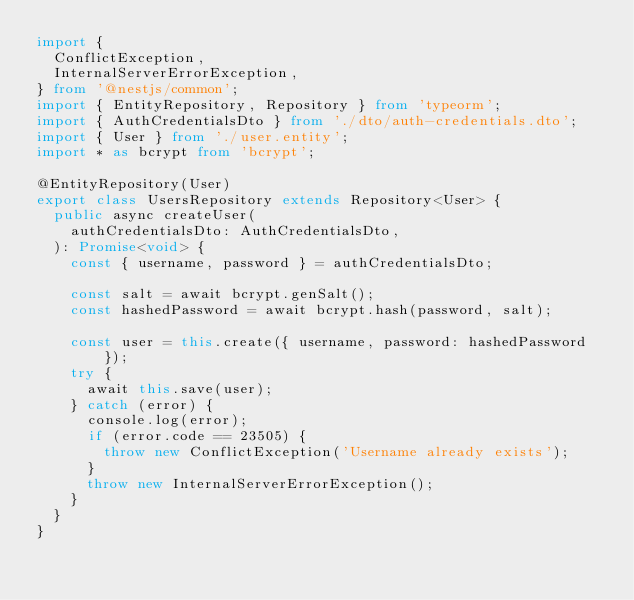Convert code to text. <code><loc_0><loc_0><loc_500><loc_500><_TypeScript_>import {
  ConflictException,
  InternalServerErrorException,
} from '@nestjs/common';
import { EntityRepository, Repository } from 'typeorm';
import { AuthCredentialsDto } from './dto/auth-credentials.dto';
import { User } from './user.entity';
import * as bcrypt from 'bcrypt';

@EntityRepository(User)
export class UsersRepository extends Repository<User> {
  public async createUser(
    authCredentialsDto: AuthCredentialsDto,
  ): Promise<void> {
    const { username, password } = authCredentialsDto;

    const salt = await bcrypt.genSalt();
    const hashedPassword = await bcrypt.hash(password, salt);

    const user = this.create({ username, password: hashedPassword });
    try {
      await this.save(user);
    } catch (error) {
      console.log(error);
      if (error.code == 23505) {
        throw new ConflictException('Username already exists');
      }
      throw new InternalServerErrorException();
    }
  }
}
</code> 